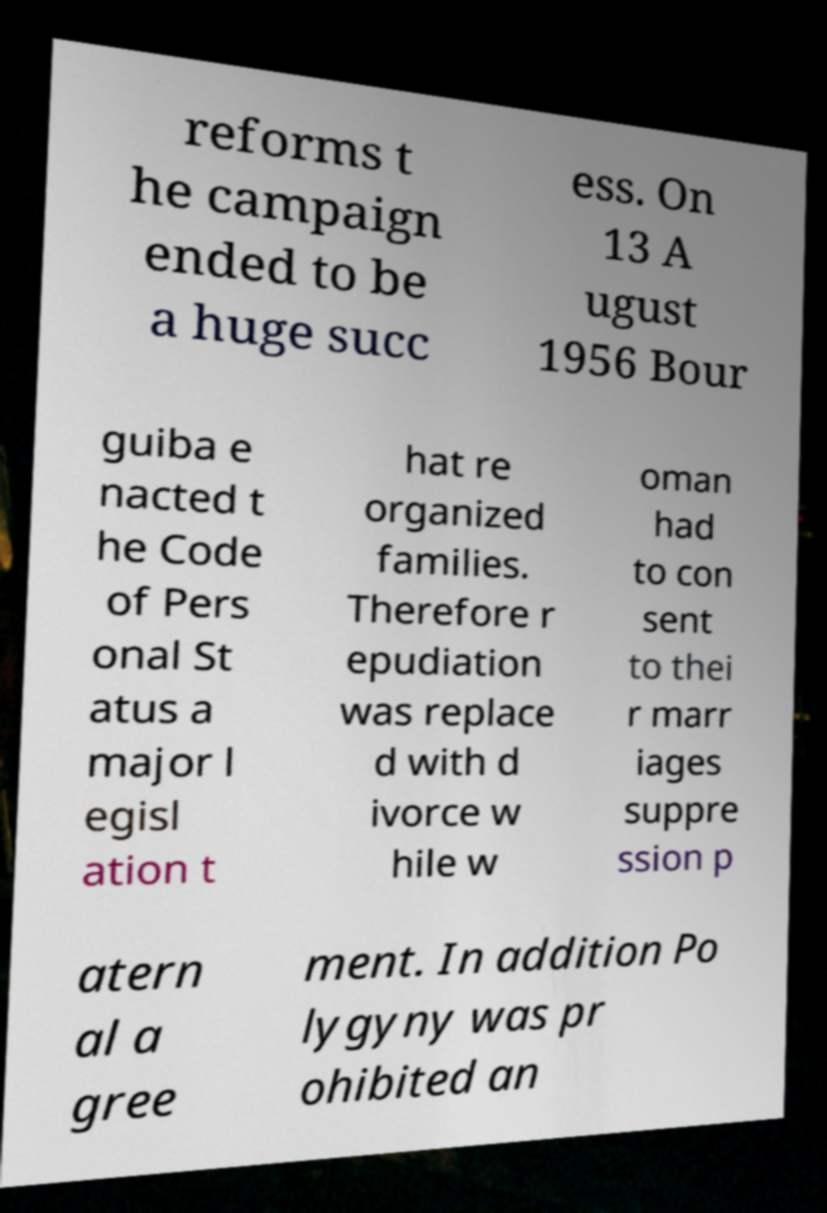Can you read and provide the text displayed in the image?This photo seems to have some interesting text. Can you extract and type it out for me? reforms t he campaign ended to be a huge succ ess. On 13 A ugust 1956 Bour guiba e nacted t he Code of Pers onal St atus a major l egisl ation t hat re organized families. Therefore r epudiation was replace d with d ivorce w hile w oman had to con sent to thei r marr iages suppre ssion p atern al a gree ment. In addition Po lygyny was pr ohibited an 